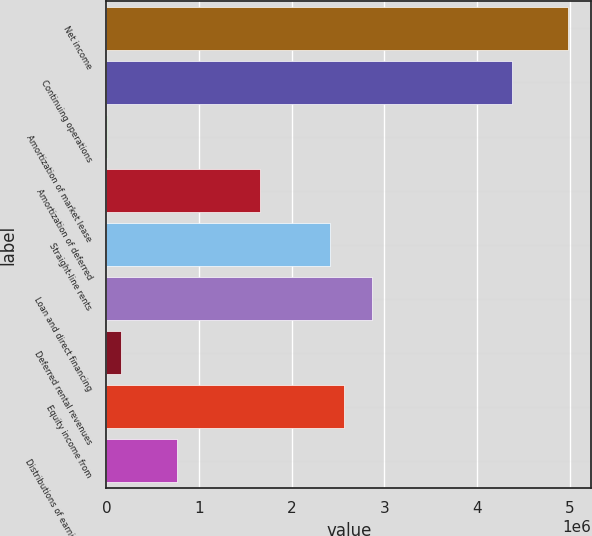Convert chart. <chart><loc_0><loc_0><loc_500><loc_500><bar_chart><fcel>Net income<fcel>Continuing operations<fcel>Amortization of market lease<fcel>Amortization of deferred<fcel>Straight-line rents<fcel>Loan and direct financing<fcel>Deferred rental revenues<fcel>Equity income from<fcel>Distributions of earnings from<nl><fcel>4.98702e+06<fcel>4.38265e+06<fcel>949<fcel>1.66297e+06<fcel>2.41844e+06<fcel>2.87172e+06<fcel>152042<fcel>2.56953e+06<fcel>756414<nl></chart> 